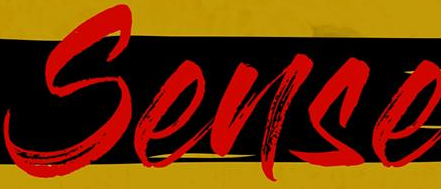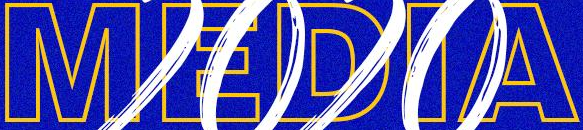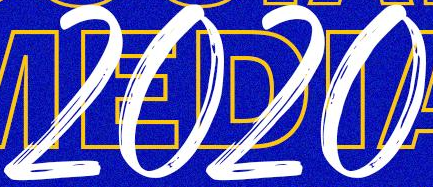Transcribe the words shown in these images in order, separated by a semicolon. Sense; MEDIA; 2020 